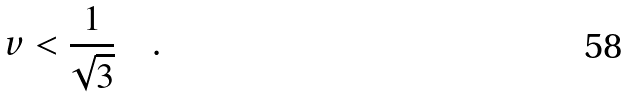Convert formula to latex. <formula><loc_0><loc_0><loc_500><loc_500>v < \frac { 1 } { \sqrt { 3 } } \quad .</formula> 